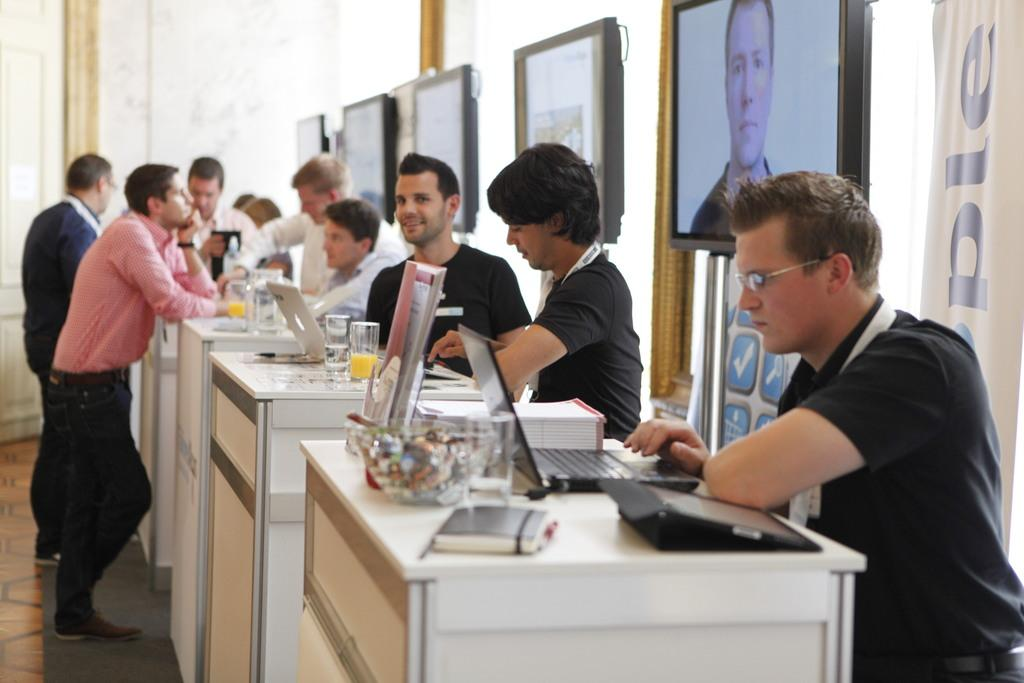Who or what can be seen in the image? There are people in the image. What are the people doing in the image? The people are standing. What objects are present on the table in the image? There are laptops on a table in the image. What type of beam can be seen supporting the table in the image? There is no beam supporting the table in the image; the table is not shown to be elevated or suspended. 